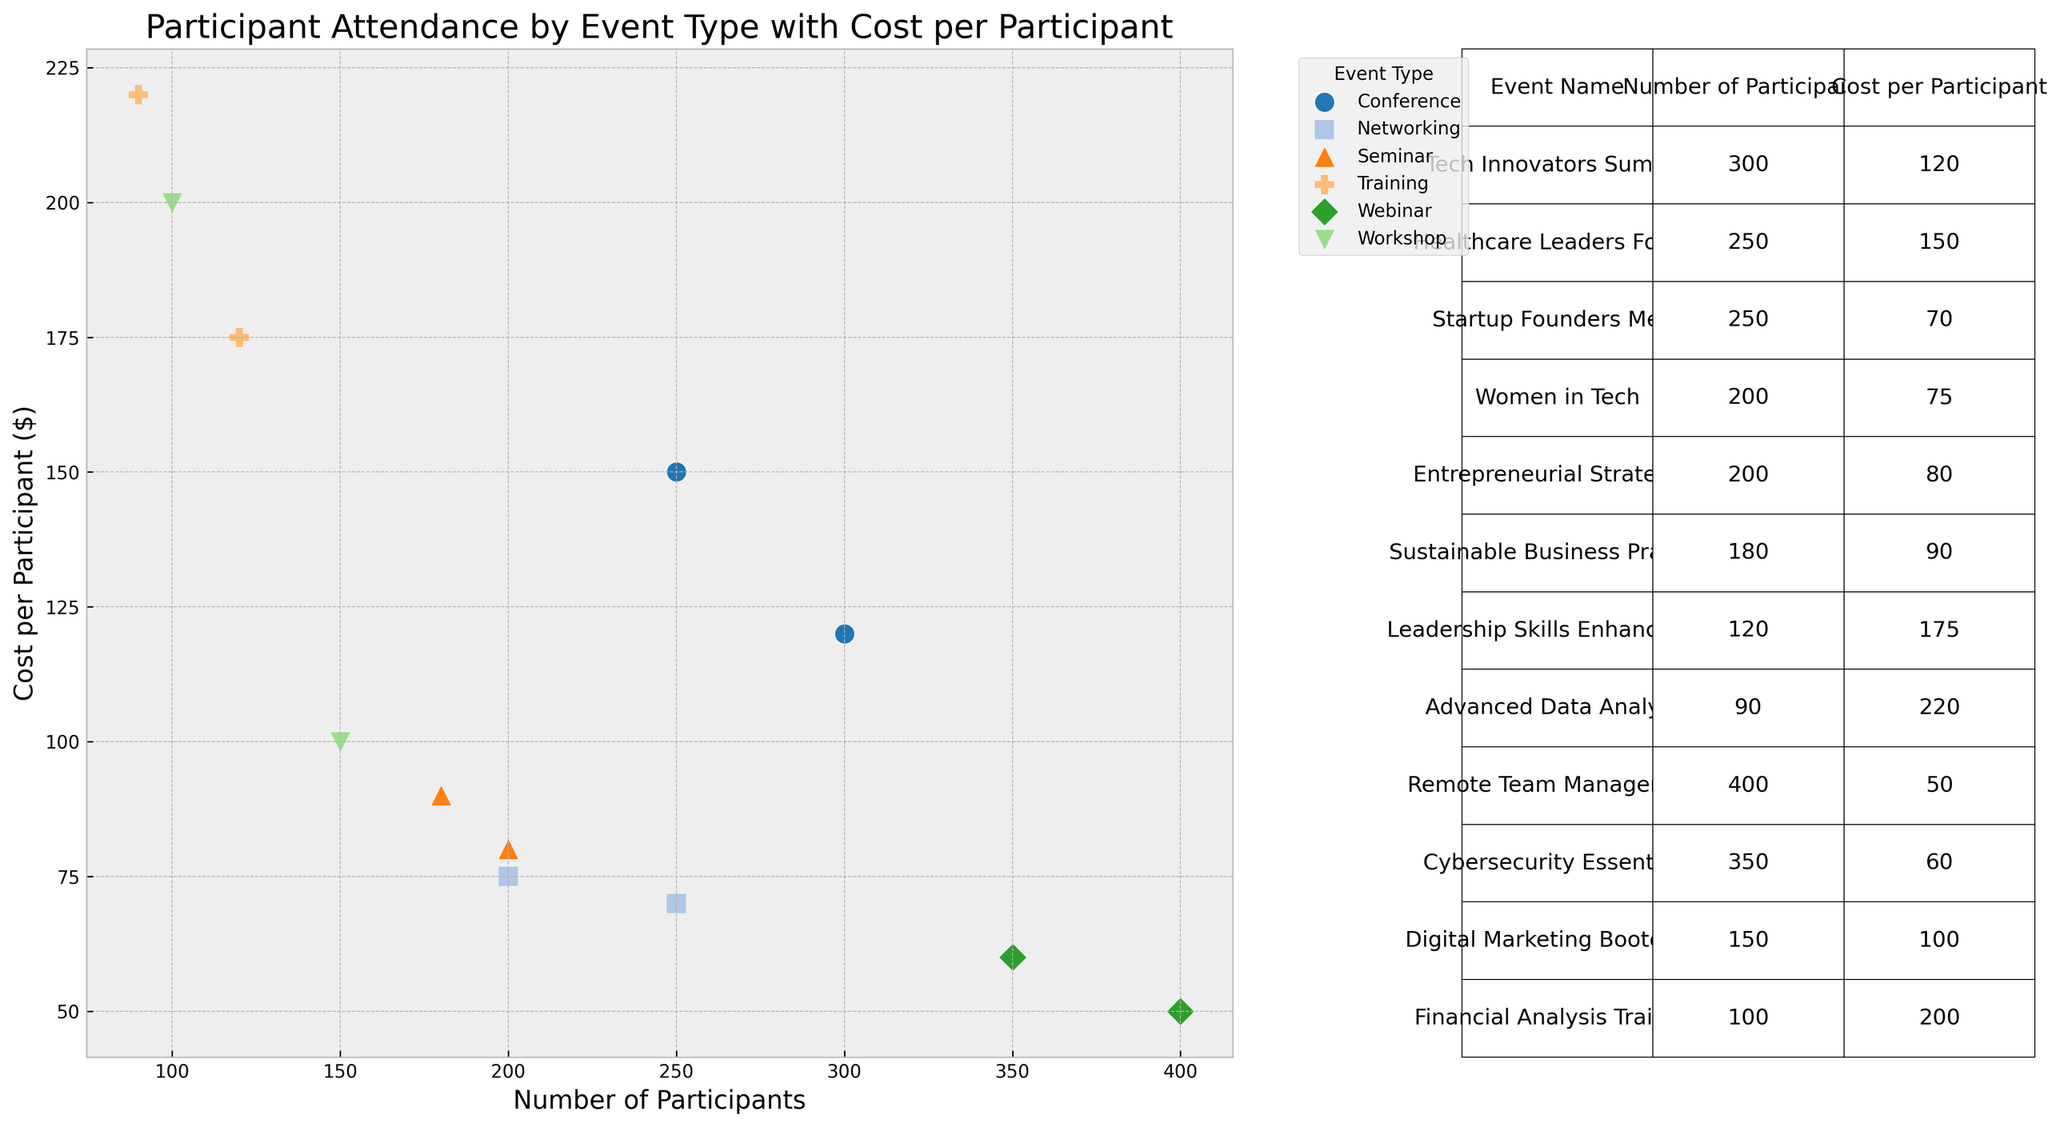What's the event type with the highest number of participants in a single event? The scatter plot or table shows each event's number of participants. The "Remote Team Management" webinar has the most participants at 400.
Answer: Webinar Which event type has the highest cost per participant? By observing the scatter plot or table, the training event "Advanced Data Analysis" has the highest cost per participant at $220.
Answer: Training What is the difference in cost per participant between the most expensive and the least expensive events? The most expensive event is "Advanced Data Analysis" with $220 per participant, and the least expensive event is "Remote Team Management" with $50 per participant. The difference is $220 - $50.
Answer: $170 Which event type has the largest range of costs per participant? By comparing the scatter plot or table, "Training" has the highest cost per participant at $220 for "Advanced Data Analysis" and $175 for "Leadership Skills Enhancement", giving a range of $175 to $220. The difference is 220 - 175.
Answer: Training by $45 How many total participants attended the seminar events? Summing the number of participants for both seminar events from the table: "Entrepreneurial Strategies" has 200 participants and "Sustainable Business Practices" has 180 participants. So, 200 + 180 = 380 participants.
Answer: 380 Which event type has events with more participants on average—conferences or workshops? The conferences have 300 and 250 participants, averaging (300+250)/2 = 275. Workshops have 150 and 100 participants, averaging (150+100)/2 = 125.
Answer: Conferences What is the total cost for participants of the "Healthcare Leaders Forum" event? The "Healthcare Leaders Forum" has 250 participants at $150 per participant. Therefore, total cost = 250 * 150.
Answer: $37,500 Which event has the smallest number of participants? Looking at the scatter plot or table, "Advanced Data Analysis" training has the smallest number of participants at 90.
Answer: Advanced Data Analysis How does the cost per participant for the "Tech Innovators Summit" compare to the "Financial Analysis Training"? "Tech Innovators Summit" has a cost per participant of $120, while "Financial Analysis Training" is $200. This means "Financial Analysis Training" costs $200 - $120 = $80 more per participant.
Answer: $80 more Between "Startup Founders Meet" and "Women in Tech", which networking event has more participants and at what cost per participant? "Startup Founders Meet" has 250 participants at $70 per participant, while "Women in Tech" has 200 participants at $75 per participant. The first event has more participants.
Answer: Startup Founders Meet, $70 